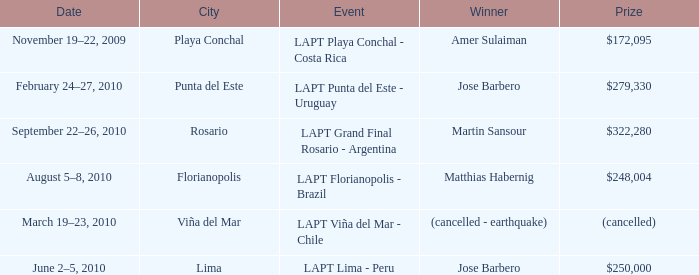Who is the winner in the city of lima? Jose Barbero. 